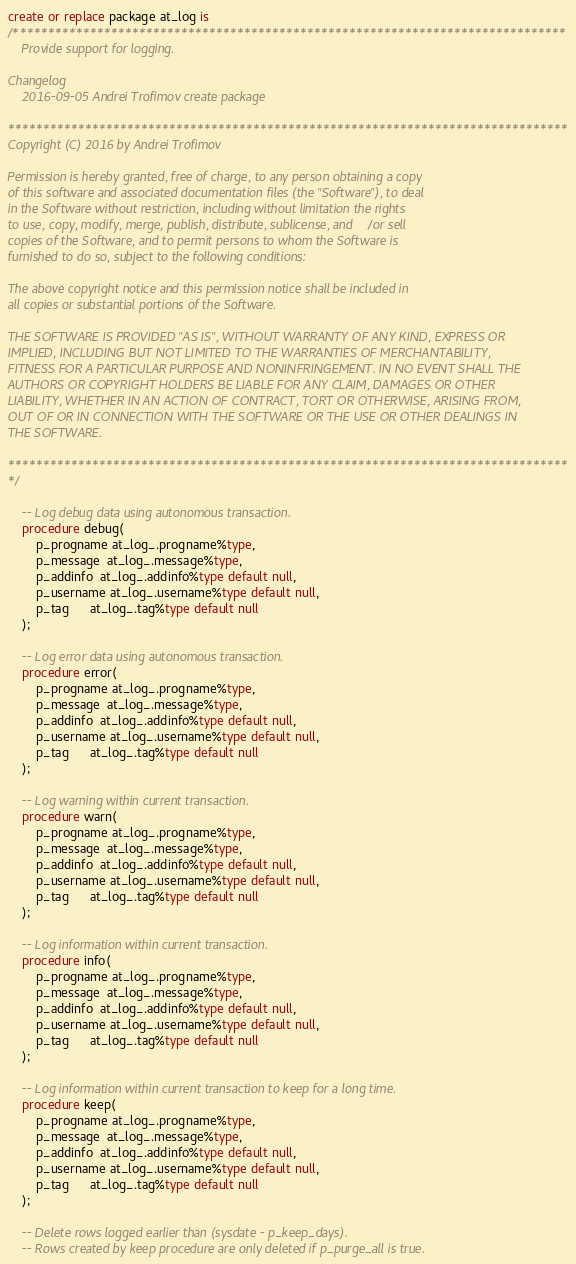Convert code to text. <code><loc_0><loc_0><loc_500><loc_500><_SQL_>create or replace package at_log is
/*******************************************************************************
    Provide support for logging.

Changelog
    2016-09-05 Andrei Trofimov create package

********************************************************************************
Copyright (C) 2016 by Andrei Trofimov

Permission is hereby granted, free of charge, to any person obtaining a copy
of this software and associated documentation files (the "Software"), to deal
in the Software without restriction, including without limitation the rights
to use, copy, modify, merge, publish, distribute, sublicense, and/or sell
copies of the Software, and to permit persons to whom the Software is
furnished to do so, subject to the following conditions:

The above copyright notice and this permission notice shall be included in
all copies or substantial portions of the Software.

THE SOFTWARE IS PROVIDED "AS IS", WITHOUT WARRANTY OF ANY KIND, EXPRESS OR
IMPLIED, INCLUDING BUT NOT LIMITED TO THE WARRANTIES OF MERCHANTABILITY,
FITNESS FOR A PARTICULAR PURPOSE AND NONINFRINGEMENT. IN NO EVENT SHALL THE
AUTHORS OR COPYRIGHT HOLDERS BE LIABLE FOR ANY CLAIM, DAMAGES OR OTHER
LIABILITY, WHETHER IN AN ACTION OF CONTRACT, TORT OR OTHERWISE, ARISING FROM,
OUT OF OR IN CONNECTION WITH THE SOFTWARE OR THE USE OR OTHER DEALINGS IN
THE SOFTWARE.

********************************************************************************
*/

    -- Log debug data using autonomous transaction.
    procedure debug(
        p_progname at_log_.progname%type,
        p_message  at_log_.message%type,
        p_addinfo  at_log_.addinfo%type default null,
        p_username at_log_.username%type default null,
        p_tag      at_log_.tag%type default null
    );

    -- Log error data using autonomous transaction.
    procedure error(
        p_progname at_log_.progname%type,
        p_message  at_log_.message%type,
        p_addinfo  at_log_.addinfo%type default null,
        p_username at_log_.username%type default null,
        p_tag      at_log_.tag%type default null
    );

    -- Log warning within current transaction.
    procedure warn(
        p_progname at_log_.progname%type,
        p_message  at_log_.message%type,
        p_addinfo  at_log_.addinfo%type default null,
        p_username at_log_.username%type default null,
        p_tag      at_log_.tag%type default null
    );

    -- Log information within current transaction.
    procedure info(
        p_progname at_log_.progname%type,
        p_message  at_log_.message%type,
        p_addinfo  at_log_.addinfo%type default null,
        p_username at_log_.username%type default null,
        p_tag      at_log_.tag%type default null
    );

    -- Log information within current transaction to keep for a long time.
    procedure keep(
        p_progname at_log_.progname%type,
        p_message  at_log_.message%type,
        p_addinfo  at_log_.addinfo%type default null,
        p_username at_log_.username%type default null,
        p_tag      at_log_.tag%type default null
    );

    -- Delete rows logged earlier than (sysdate - p_keep_days).
    -- Rows created by keep procedure are only deleted if p_purge_all is true.</code> 